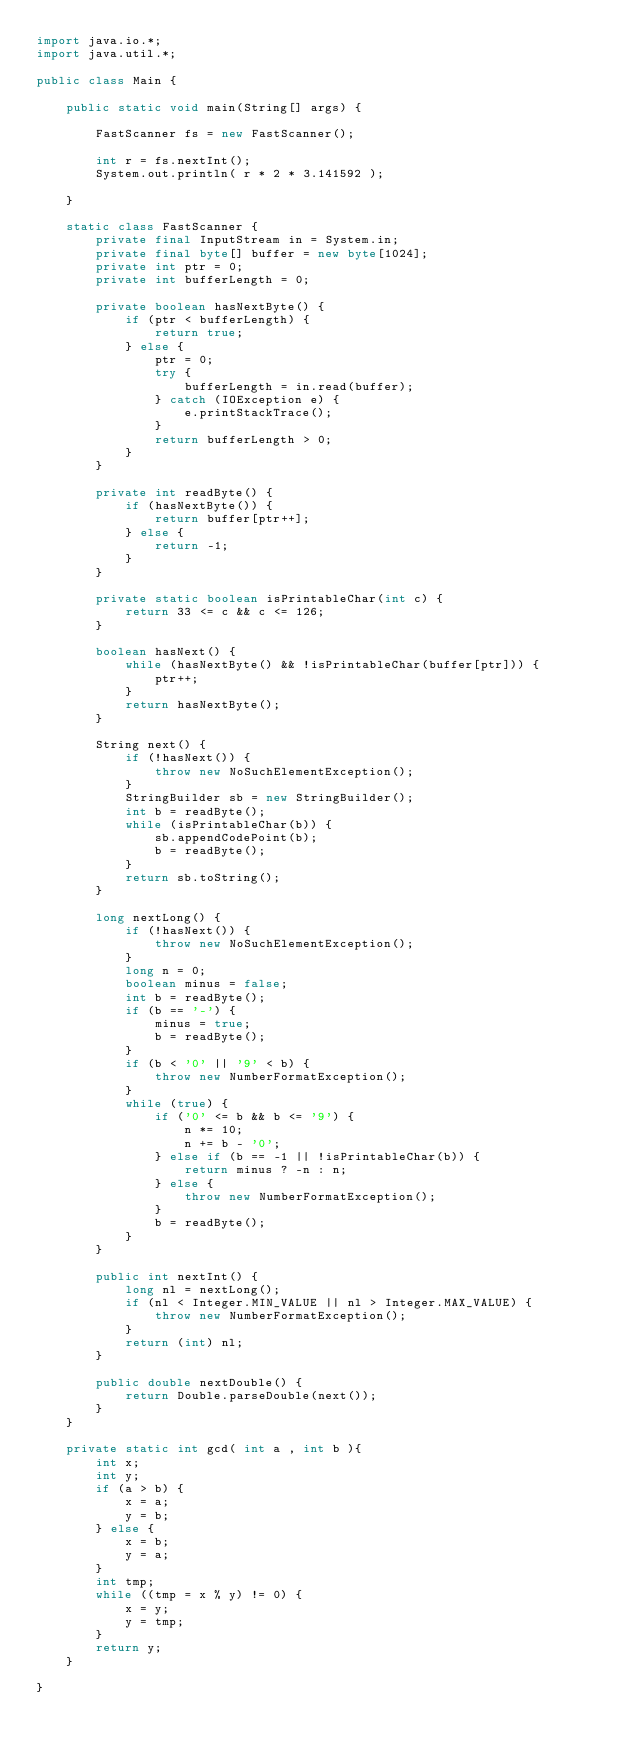Convert code to text. <code><loc_0><loc_0><loc_500><loc_500><_Java_>import java.io.*;
import java.util.*;

public class Main {

    public static void main(String[] args) {

        FastScanner fs = new FastScanner();

        int r = fs.nextInt();
        System.out.println( r * 2 * 3.141592 );

    }

    static class FastScanner {
        private final InputStream in = System.in;
        private final byte[] buffer = new byte[1024];
        private int ptr = 0;
        private int bufferLength = 0;

        private boolean hasNextByte() {
            if (ptr < bufferLength) {
                return true;
            } else {
                ptr = 0;
                try {
                    bufferLength = in.read(buffer);
                } catch (IOException e) {
                    e.printStackTrace();
                }
                return bufferLength > 0;
            }
        }

        private int readByte() {
            if (hasNextByte()) {
                return buffer[ptr++];
            } else {
                return -1;
            }
        }

        private static boolean isPrintableChar(int c) {
            return 33 <= c && c <= 126;
        }

        boolean hasNext() {
            while (hasNextByte() && !isPrintableChar(buffer[ptr])) {
                ptr++;
            }
            return hasNextByte();
        }

        String next() {
            if (!hasNext()) {
                throw new NoSuchElementException();
            }
            StringBuilder sb = new StringBuilder();
            int b = readByte();
            while (isPrintableChar(b)) {
                sb.appendCodePoint(b);
                b = readByte();
            }
            return sb.toString();
        }

        long nextLong() {
            if (!hasNext()) {
                throw new NoSuchElementException();
            }
            long n = 0;
            boolean minus = false;
            int b = readByte();
            if (b == '-') {
                minus = true;
                b = readByte();
            }
            if (b < '0' || '9' < b) {
                throw new NumberFormatException();
            }
            while (true) {
                if ('0' <= b && b <= '9') {
                    n *= 10;
                    n += b - '0';
                } else if (b == -1 || !isPrintableChar(b)) {
                    return minus ? -n : n;
                } else {
                    throw new NumberFormatException();
                }
                b = readByte();
            }
        }

        public int nextInt() {
            long nl = nextLong();
            if (nl < Integer.MIN_VALUE || nl > Integer.MAX_VALUE) {
                throw new NumberFormatException();
            }
            return (int) nl;
        }

        public double nextDouble() {
            return Double.parseDouble(next());
        }
    }

    private static int gcd( int a , int b ){
        int x;
        int y;
        if (a > b) {
            x = a;
            y = b;
        } else {
            x = b;
            y = a;
        }
        int tmp;
        while ((tmp = x % y) != 0) {
            x = y;
            y = tmp;
        }
        return y;
    }

}
</code> 